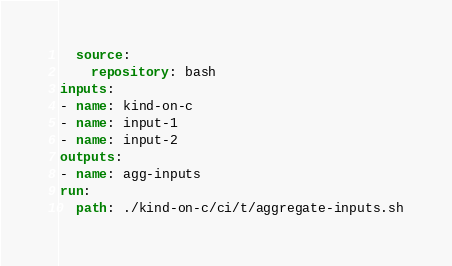<code> <loc_0><loc_0><loc_500><loc_500><_YAML_>  source:
    repository: bash
inputs:
- name: kind-on-c
- name: input-1
- name: input-2
outputs:
- name: agg-inputs
run:
  path: ./kind-on-c/ci/t/aggregate-inputs.sh
</code> 